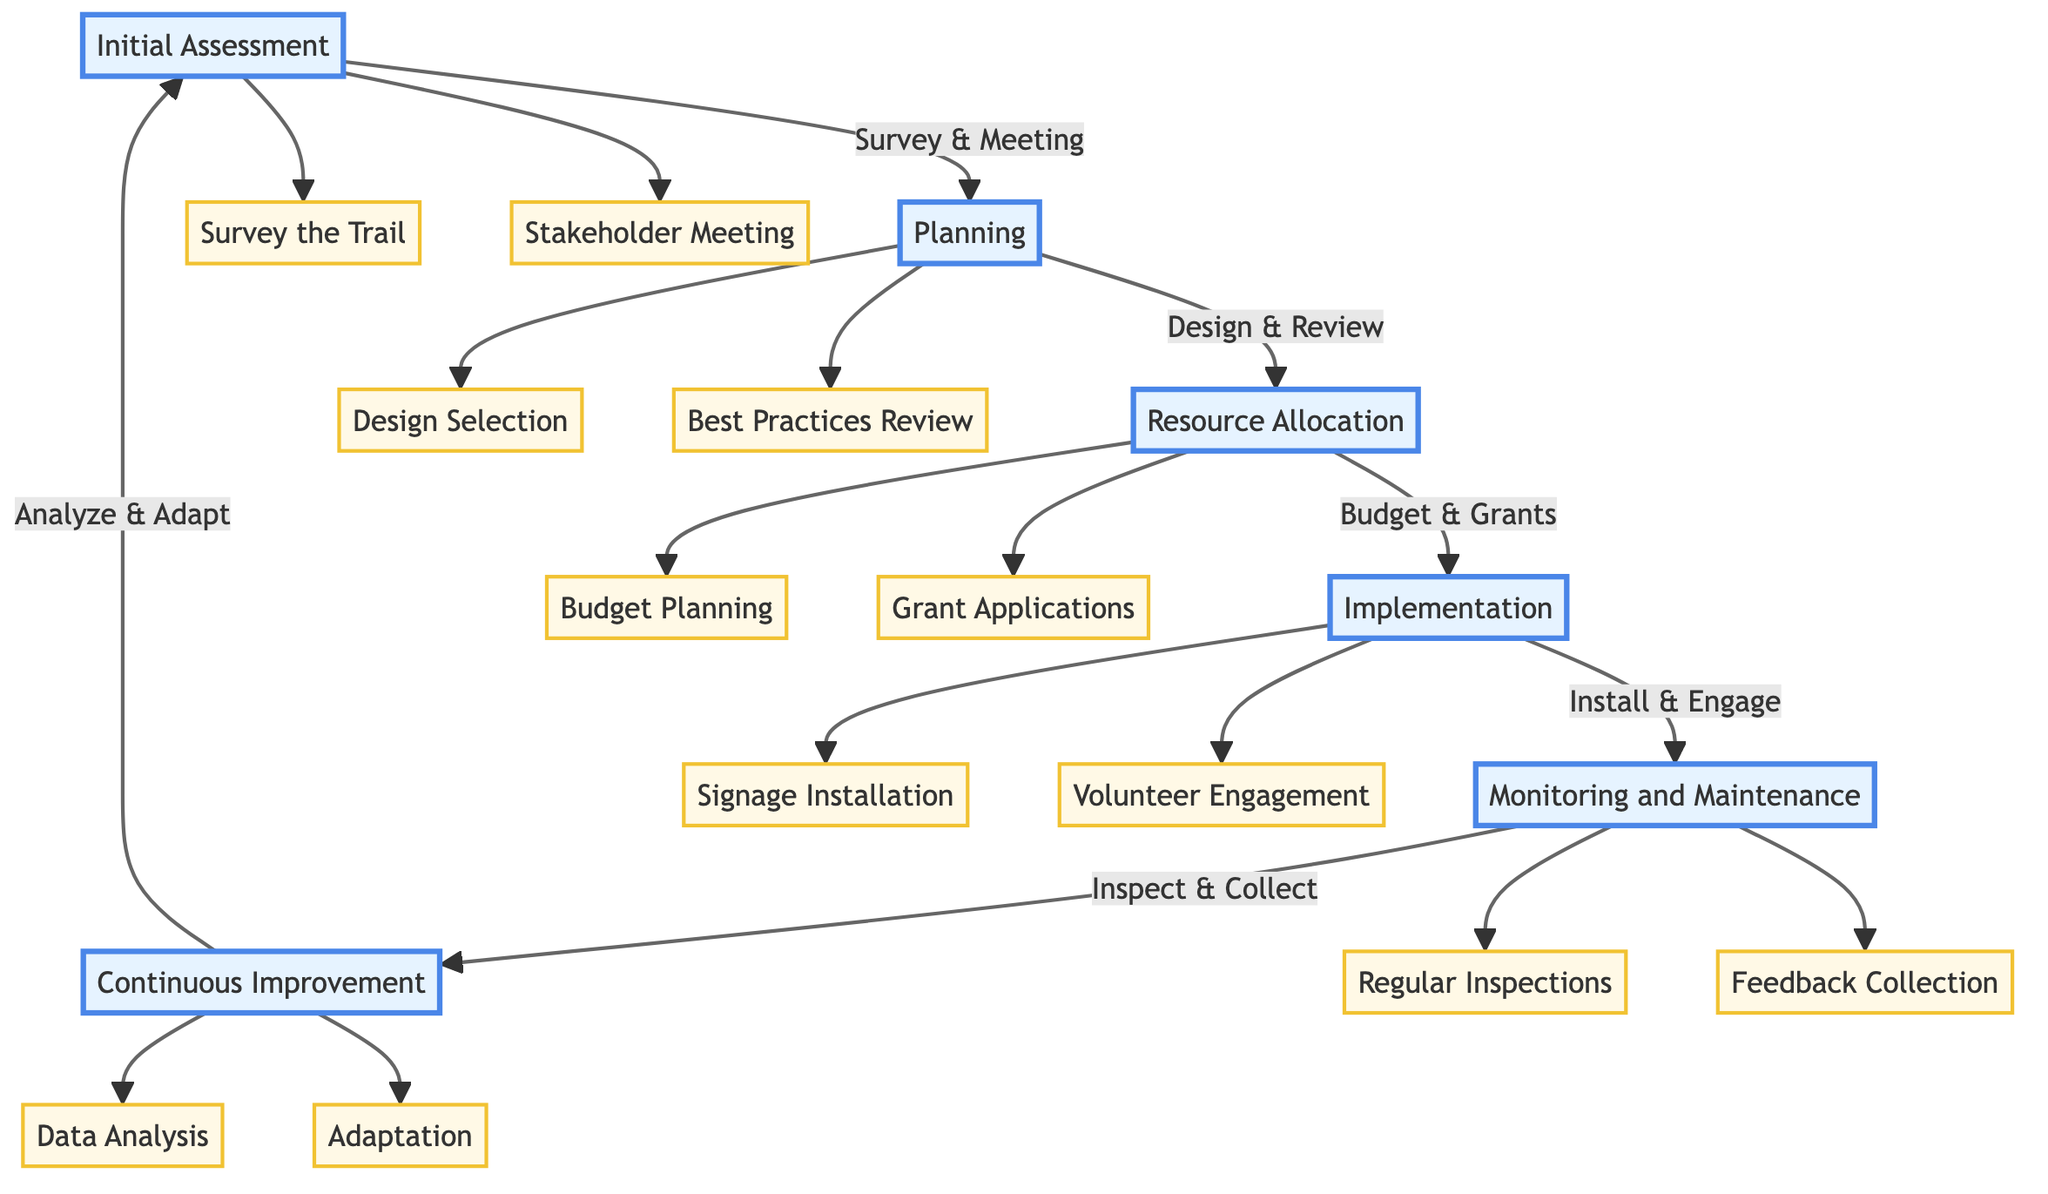What is the first step in the pathway? The first step, indicated by the starting point of the diagram, is "Survey the Trail," which is part of the "Initial Assessment" phase.
Answer: Survey the Trail How many phases are in the diagram? The diagram consists of six phases, namely Initial Assessment, Planning, Resource Allocation, Implementation, Monitoring and Maintenance, and Continuous Improvement.
Answer: Six What actions are taken during the Planning phase? The Planning phase includes two actions: "Design Selection" and "Best Practices Review," both of which are found underneath the Planning node.
Answer: Design Selection and Best Practices Review Which phase follows Resource Allocation? The phase that immediately follows "Resource Allocation" in the diagram is "Implementation," showing the order of actions taken.
Answer: Implementation How many actions are involved in the Monitoring and Maintenance phase? The Monitoring and Maintenance phase consists of two actions: "Regular Inspections" and "Feedback Collection," indicating that there are two actions in this phase.
Answer: Two What action is taken after the "Signage Installation"? After "Signage Installation," the next action is "Volunteer Engagement," which follows directly in the pathway flow.
Answer: Volunteer Engagement Which phases involve feedback collection? Feedback collection occurs in the Monitoring and Maintenance phase, which specifically includes the action "Feedback Collection" aimed at gathering input from hikers and volunteers.
Answer: Monitoring and Maintenance What happens after the Continuous Improvement phase? The next action after the Continuous Improvement phase is "Analyze," which is part of the actions that continuously refine the trail signage based on new data insights.
Answer: Analyze What action is associated with resource allocation for budgeting? The action specifically associated with resource allocation for budgeting is "Budget Planning," which outlines the need for sustainable materials and maintenance costs.
Answer: Budget Planning 